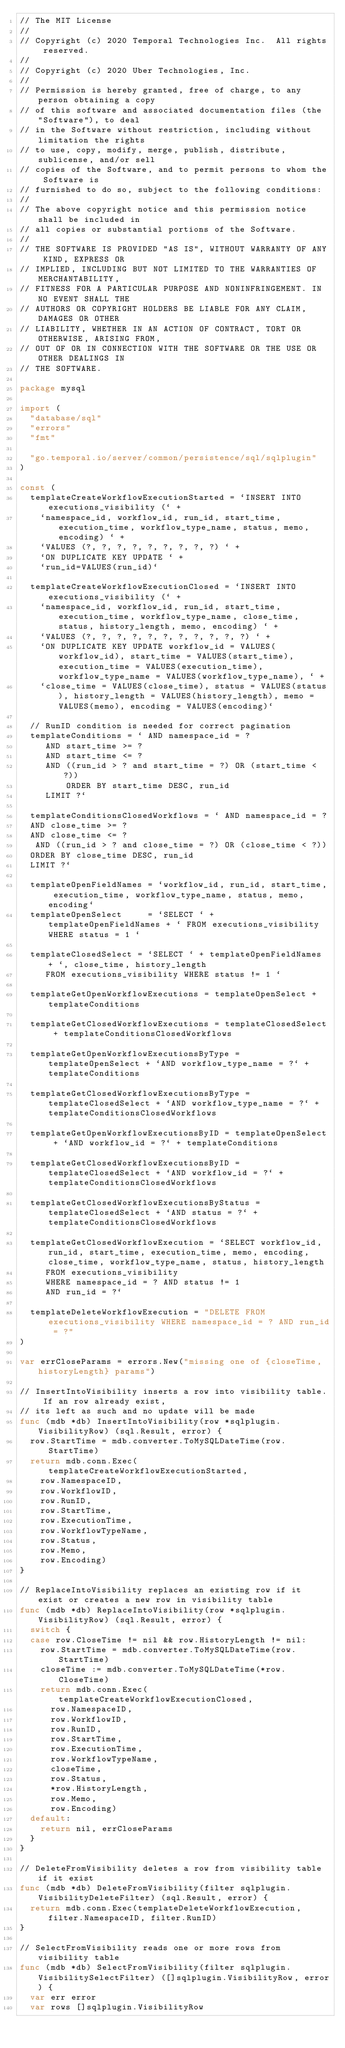Convert code to text. <code><loc_0><loc_0><loc_500><loc_500><_Go_>// The MIT License
//
// Copyright (c) 2020 Temporal Technologies Inc.  All rights reserved.
//
// Copyright (c) 2020 Uber Technologies, Inc.
//
// Permission is hereby granted, free of charge, to any person obtaining a copy
// of this software and associated documentation files (the "Software"), to deal
// in the Software without restriction, including without limitation the rights
// to use, copy, modify, merge, publish, distribute, sublicense, and/or sell
// copies of the Software, and to permit persons to whom the Software is
// furnished to do so, subject to the following conditions:
//
// The above copyright notice and this permission notice shall be included in
// all copies or substantial portions of the Software.
//
// THE SOFTWARE IS PROVIDED "AS IS", WITHOUT WARRANTY OF ANY KIND, EXPRESS OR
// IMPLIED, INCLUDING BUT NOT LIMITED TO THE WARRANTIES OF MERCHANTABILITY,
// FITNESS FOR A PARTICULAR PURPOSE AND NONINFRINGEMENT. IN NO EVENT SHALL THE
// AUTHORS OR COPYRIGHT HOLDERS BE LIABLE FOR ANY CLAIM, DAMAGES OR OTHER
// LIABILITY, WHETHER IN AN ACTION OF CONTRACT, TORT OR OTHERWISE, ARISING FROM,
// OUT OF OR IN CONNECTION WITH THE SOFTWARE OR THE USE OR OTHER DEALINGS IN
// THE SOFTWARE.

package mysql

import (
	"database/sql"
	"errors"
	"fmt"

	"go.temporal.io/server/common/persistence/sql/sqlplugin"
)

const (
	templateCreateWorkflowExecutionStarted = `INSERT INTO executions_visibility (` +
		`namespace_id, workflow_id, run_id, start_time, execution_time, workflow_type_name, status, memo, encoding) ` +
		`VALUES (?, ?, ?, ?, ?, ?, ?, ?, ?) ` +
		`ON DUPLICATE KEY UPDATE ` +
		`run_id=VALUES(run_id)`

	templateCreateWorkflowExecutionClosed = `INSERT INTO executions_visibility (` +
		`namespace_id, workflow_id, run_id, start_time, execution_time, workflow_type_name, close_time, status, history_length, memo, encoding) ` +
		`VALUES (?, ?, ?, ?, ?, ?, ?, ?, ?, ?, ?) ` +
		`ON DUPLICATE KEY UPDATE workflow_id = VALUES(workflow_id), start_time = VALUES(start_time), execution_time = VALUES(execution_time), workflow_type_name = VALUES(workflow_type_name), ` +
		`close_time = VALUES(close_time), status = VALUES(status), history_length = VALUES(history_length), memo = VALUES(memo), encoding = VALUES(encoding)`

	// RunID condition is needed for correct pagination
	templateConditions = ` AND namespace_id = ?
		 AND start_time >= ?
		 AND start_time <= ?
 		 AND ((run_id > ? and start_time = ?) OR (start_time < ?))
         ORDER BY start_time DESC, run_id
		 LIMIT ?`

	templateConditionsClosedWorkflows = ` AND namespace_id = ?
	AND close_time >= ?
	AND close_time <= ?
	 AND ((run_id > ? and close_time = ?) OR (close_time < ?))
	ORDER BY close_time DESC, run_id
	LIMIT ?`

	templateOpenFieldNames = `workflow_id, run_id, start_time, execution_time, workflow_type_name, status, memo, encoding`
	templateOpenSelect     = `SELECT ` + templateOpenFieldNames + ` FROM executions_visibility WHERE status = 1 `

	templateClosedSelect = `SELECT ` + templateOpenFieldNames + `, close_time, history_length
		 FROM executions_visibility WHERE status != 1 `

	templateGetOpenWorkflowExecutions = templateOpenSelect + templateConditions

	templateGetClosedWorkflowExecutions = templateClosedSelect + templateConditionsClosedWorkflows

	templateGetOpenWorkflowExecutionsByType = templateOpenSelect + `AND workflow_type_name = ?` + templateConditions

	templateGetClosedWorkflowExecutionsByType = templateClosedSelect + `AND workflow_type_name = ?` + templateConditionsClosedWorkflows

	templateGetOpenWorkflowExecutionsByID = templateOpenSelect + `AND workflow_id = ?` + templateConditions

	templateGetClosedWorkflowExecutionsByID = templateClosedSelect + `AND workflow_id = ?` + templateConditionsClosedWorkflows

	templateGetClosedWorkflowExecutionsByStatus = templateClosedSelect + `AND status = ?` + templateConditionsClosedWorkflows

	templateGetClosedWorkflowExecution = `SELECT workflow_id, run_id, start_time, execution_time, memo, encoding, close_time, workflow_type_name, status, history_length 
		 FROM executions_visibility
		 WHERE namespace_id = ? AND status != 1
		 AND run_id = ?`

	templateDeleteWorkflowExecution = "DELETE FROM executions_visibility WHERE namespace_id = ? AND run_id = ?"
)

var errCloseParams = errors.New("missing one of {closeTime, historyLength} params")

// InsertIntoVisibility inserts a row into visibility table. If an row already exist,
// its left as such and no update will be made
func (mdb *db) InsertIntoVisibility(row *sqlplugin.VisibilityRow) (sql.Result, error) {
	row.StartTime = mdb.converter.ToMySQLDateTime(row.StartTime)
	return mdb.conn.Exec(templateCreateWorkflowExecutionStarted,
		row.NamespaceID,
		row.WorkflowID,
		row.RunID,
		row.StartTime,
		row.ExecutionTime,
		row.WorkflowTypeName,
		row.Status,
		row.Memo,
		row.Encoding)
}

// ReplaceIntoVisibility replaces an existing row if it exist or creates a new row in visibility table
func (mdb *db) ReplaceIntoVisibility(row *sqlplugin.VisibilityRow) (sql.Result, error) {
	switch {
	case row.CloseTime != nil && row.HistoryLength != nil:
		row.StartTime = mdb.converter.ToMySQLDateTime(row.StartTime)
		closeTime := mdb.converter.ToMySQLDateTime(*row.CloseTime)
		return mdb.conn.Exec(templateCreateWorkflowExecutionClosed,
			row.NamespaceID,
			row.WorkflowID,
			row.RunID,
			row.StartTime,
			row.ExecutionTime,
			row.WorkflowTypeName,
			closeTime,
			row.Status,
			*row.HistoryLength,
			row.Memo,
			row.Encoding)
	default:
		return nil, errCloseParams
	}
}

// DeleteFromVisibility deletes a row from visibility table if it exist
func (mdb *db) DeleteFromVisibility(filter sqlplugin.VisibilityDeleteFilter) (sql.Result, error) {
	return mdb.conn.Exec(templateDeleteWorkflowExecution, filter.NamespaceID, filter.RunID)
}

// SelectFromVisibility reads one or more rows from visibility table
func (mdb *db) SelectFromVisibility(filter sqlplugin.VisibilitySelectFilter) ([]sqlplugin.VisibilityRow, error) {
	var err error
	var rows []sqlplugin.VisibilityRow</code> 